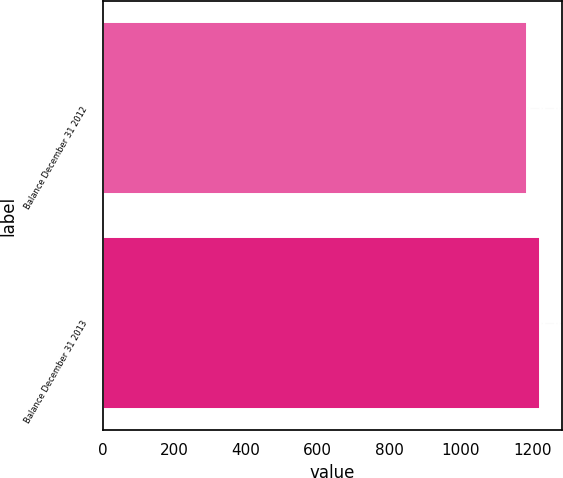Convert chart to OTSL. <chart><loc_0><loc_0><loc_500><loc_500><bar_chart><fcel>Balance December 31 2012<fcel>Balance December 31 2013<nl><fcel>1186<fcel>1221<nl></chart> 